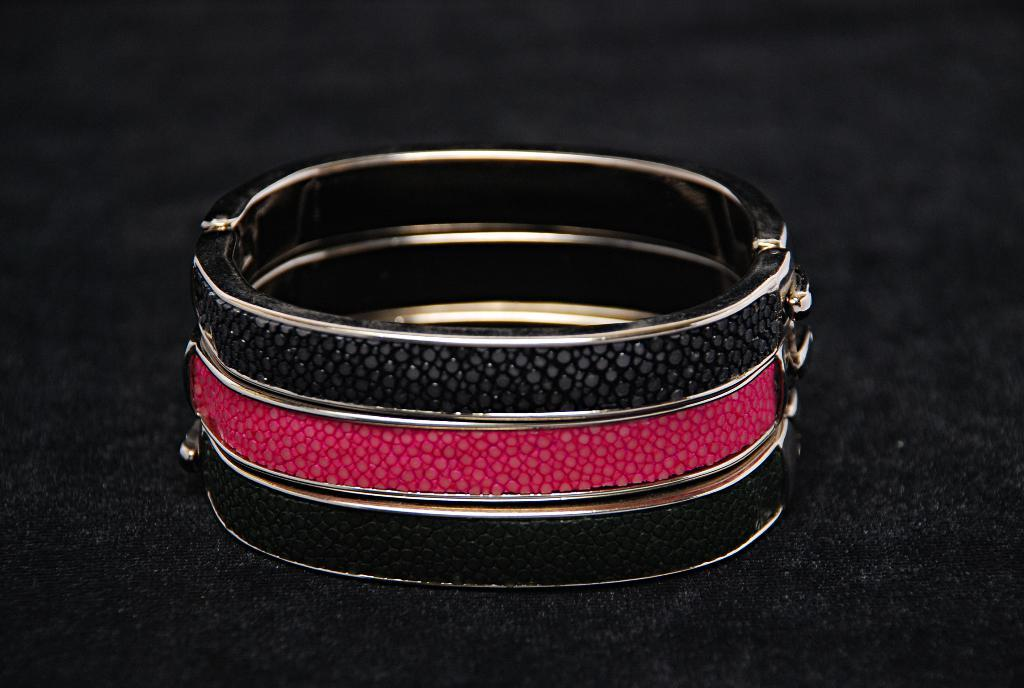What is on the floor in the image? There is a bracelet on the floor in the image. What type of button can be seen on the bracelet in the image? There is no button present on the bracelet in the image. What kind of coil is visible on the bracelet in the image? There is no coil present on the bracelet in the image. 